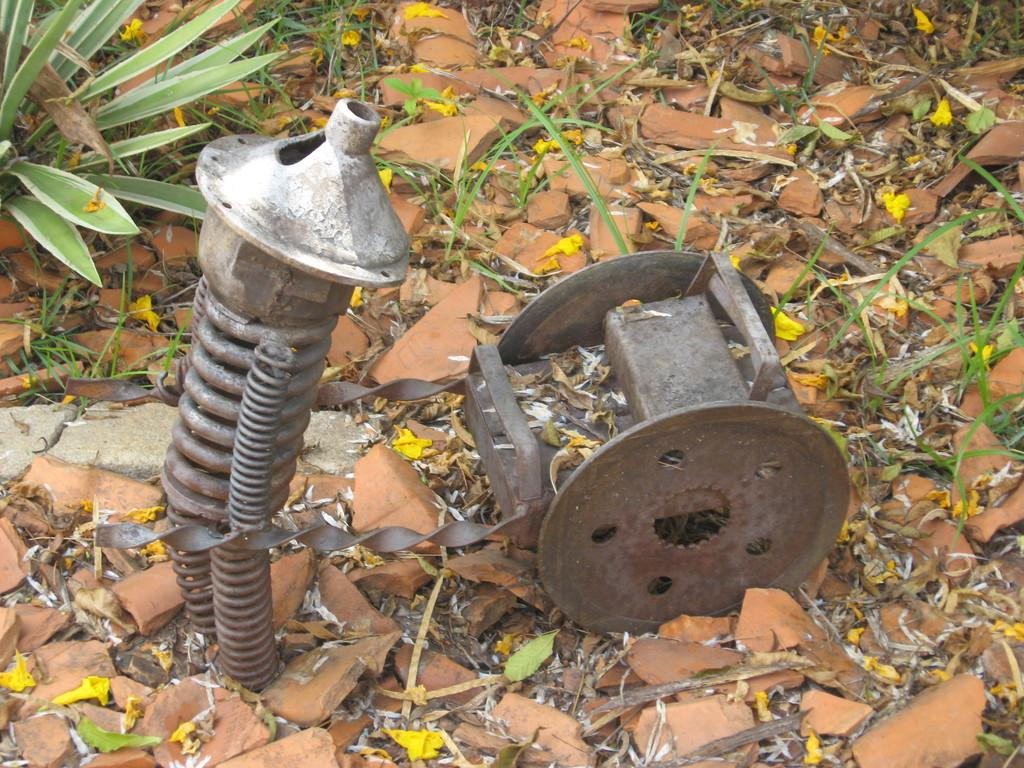What type of objects can be seen in the image? There are metal objects in the image. What other elements can be found in the image? There are plants, stones, and dried leaves in the image. How does the chain rub against the metal objects in the image? There is no chain present in the image, so it cannot rub against the metal objects. 